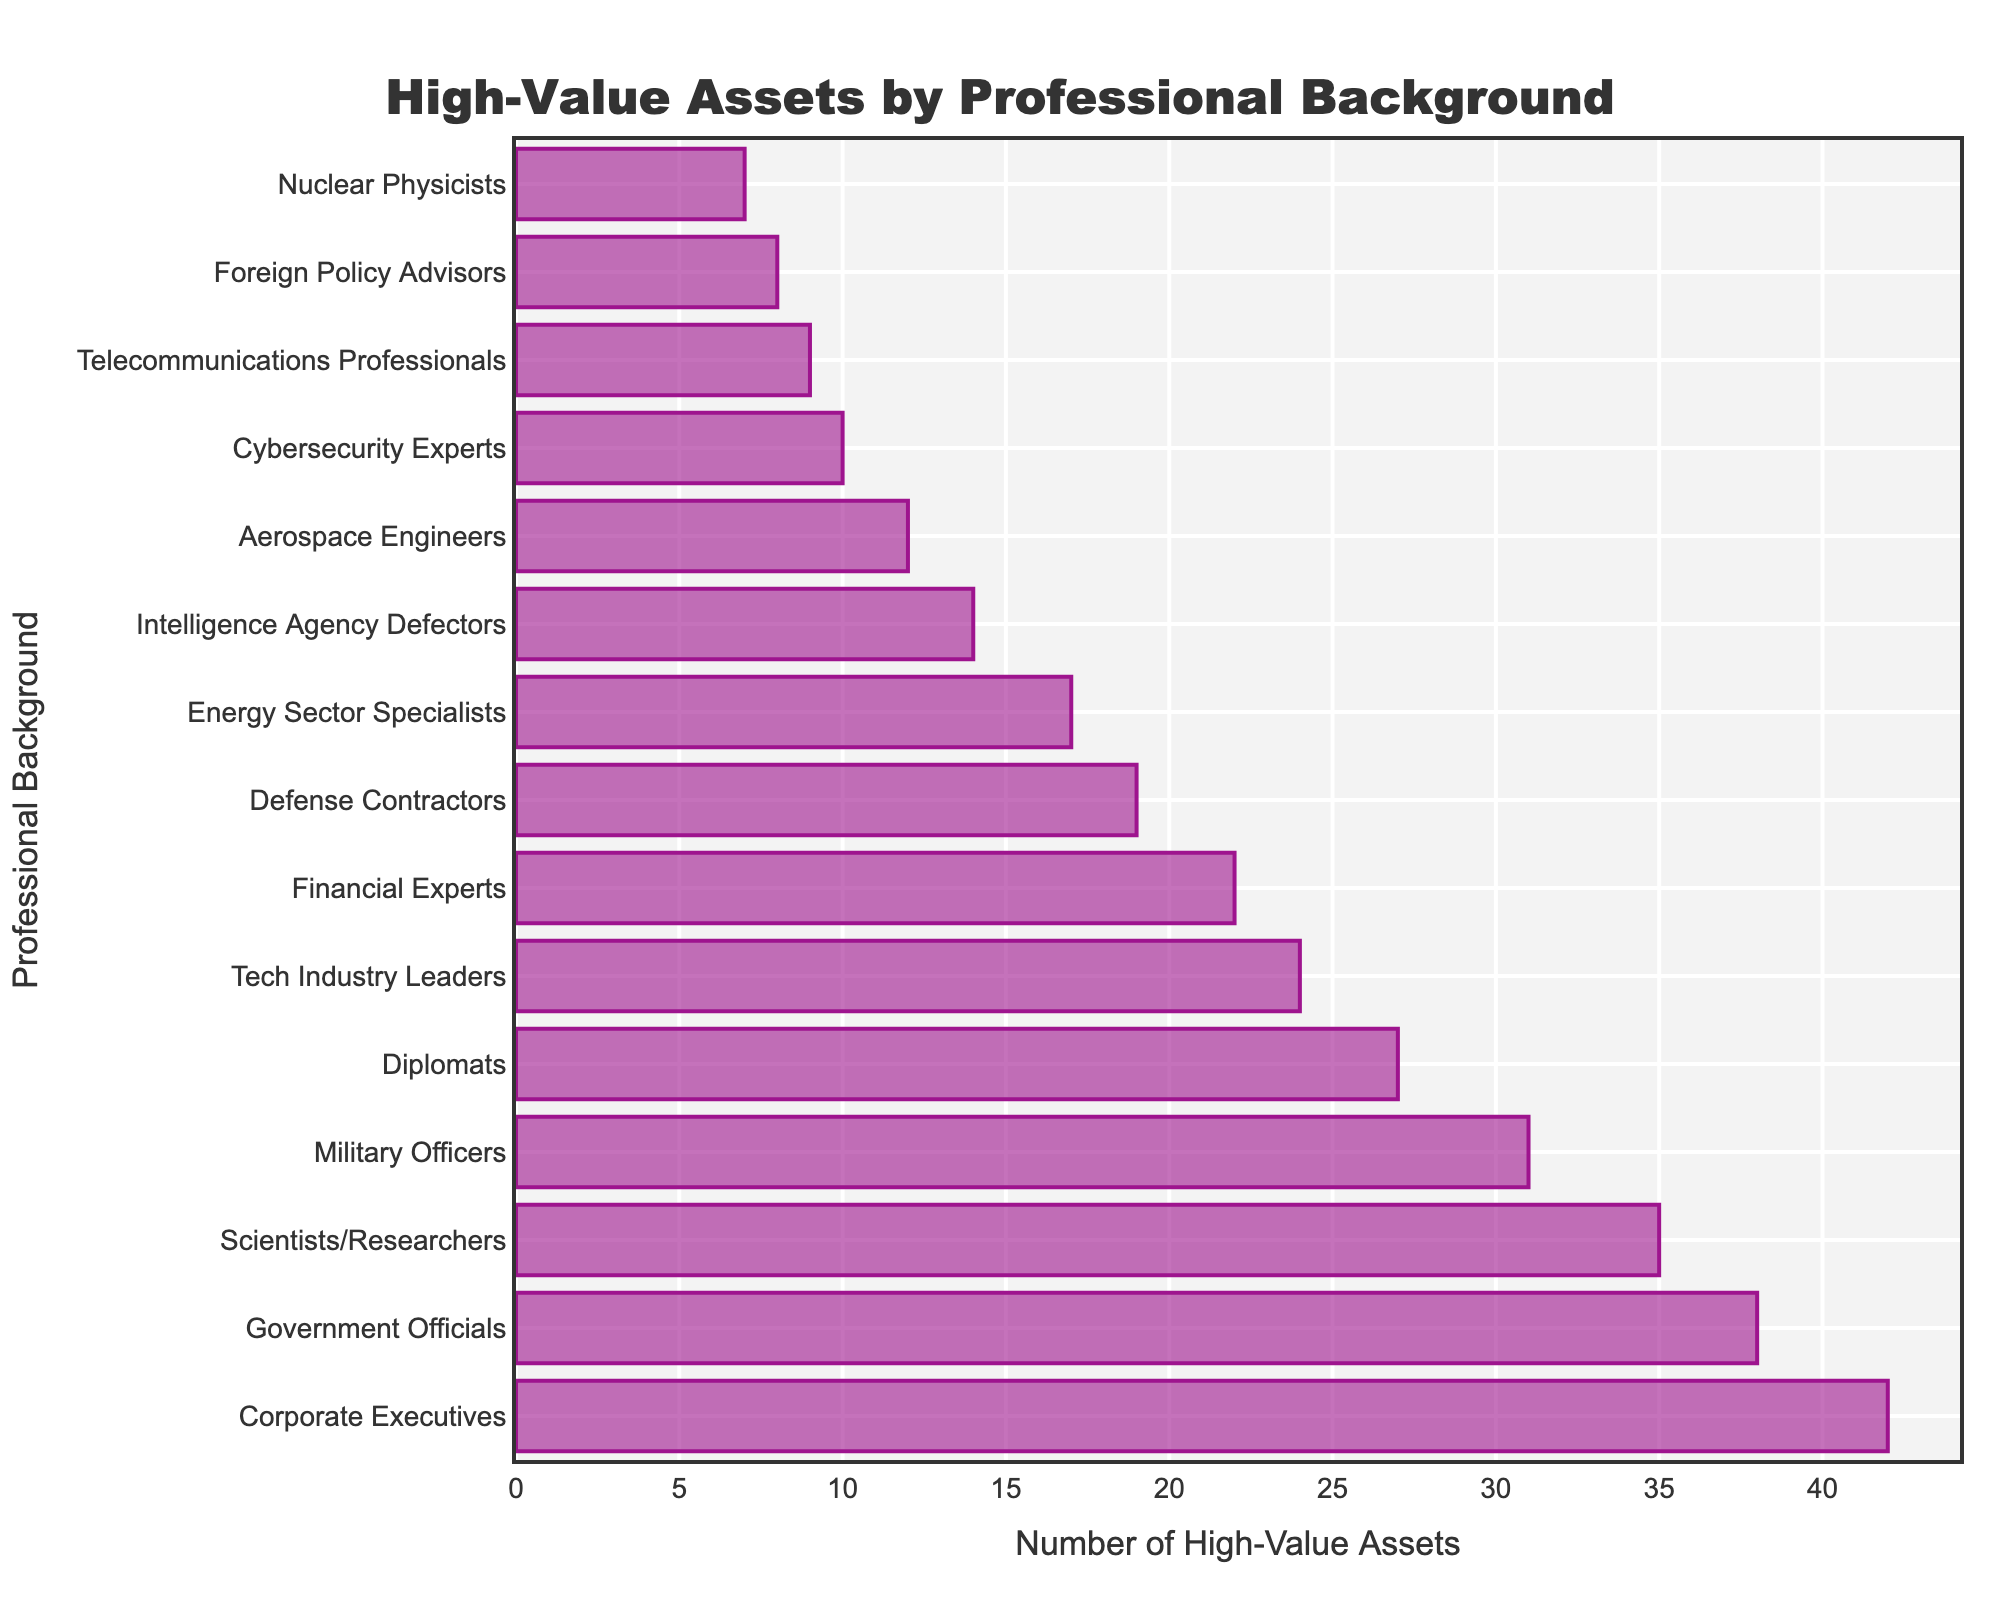Which professional background has the highest number of high-value assets? The figure shows the number of high-value assets for various professional backgrounds. By examining the length of the bars, the longest bar corresponds to "Corporate Executives" with 42 assets.
Answer: Corporate Executives What is the total number of high-value assets for Government Officials and Scientists/Researchers combined? The values for Government Officials and Scientists/Researchers are 38 and 35 respectively. Summing them up: 38 + 35 = 73.
Answer: 73 Which group has fewer high-value assets, Financial Experts or Energy Sector Specialists? Comparing the lengths of the bars for Financial Experts and Energy Sector Specialists, Financial Experts have 22 and Energy Sector Specialists have 17, so Energy Sector Specialists have fewer assets.
Answer: Energy Sector Specialists How many more high-value assets are there in Corporate Executives compared to Military Officers? The number for Corporate Executives is 42, and for Military Officers is 31. The difference is calculated as 42 - 31 = 11.
Answer: 11 What's the median number of high-value assets amongst the listed professional backgrounds? First, order the number of assets: 7, 8, 9, 10, 12, 14, 17, 19, 22, 24, 27, 31, 35, 38, 42. With 15 values, the median is the 8th value, which is 19.
Answer: 19 Which groups have a combined total of less than 20 high-value assets? Checking the figure, only Nuclear Physicists (7) and Foreign Policy Advisors (8) both have a total of 15, which is less than 20.
Answer: Nuclear Physicists and Foreign Policy Advisors Do Cybersecurity Experts have more or fewer high-value assets than Foreign Policy Advisors? By comparing the bar lengths, Cybersecurity Experts have 10 while Foreign Policy Advisors have 8, so Cybersecurity Experts have more.
Answer: More What is the average number of high-value assets for Tech Industry Leaders, Defense Contractors, and Aerospace Engineers? Summing their assets: 24 (Tech Industry Leaders) + 19 (Defense Contractors) + 12 (Aerospace Engineers) = 55, then dividing by 3: 55 / 3 ≈ 18.33.
Answer: 18.33 Which professional backgrounds have identical numbers of high-value assets, if any? Scanning the bar lengths, no two bars have identical values; each group has a unique number of high-value assets.
Answer: None What is the difference between the highest and lowest number of high-value assets in the chart? The highest value is for Corporate Executives (42) and the lowest is for Nuclear Physicists (7). The difference is 42 - 7 = 35.
Answer: 35 